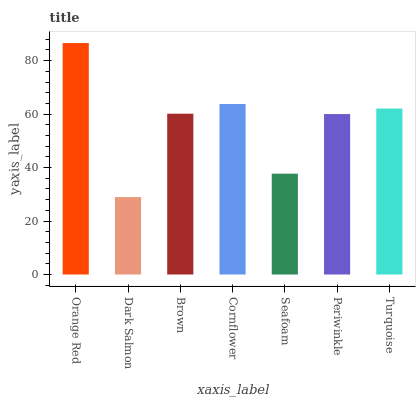Is Dark Salmon the minimum?
Answer yes or no. Yes. Is Orange Red the maximum?
Answer yes or no. Yes. Is Brown the minimum?
Answer yes or no. No. Is Brown the maximum?
Answer yes or no. No. Is Brown greater than Dark Salmon?
Answer yes or no. Yes. Is Dark Salmon less than Brown?
Answer yes or no. Yes. Is Dark Salmon greater than Brown?
Answer yes or no. No. Is Brown less than Dark Salmon?
Answer yes or no. No. Is Brown the high median?
Answer yes or no. Yes. Is Brown the low median?
Answer yes or no. Yes. Is Orange Red the high median?
Answer yes or no. No. Is Periwinkle the low median?
Answer yes or no. No. 